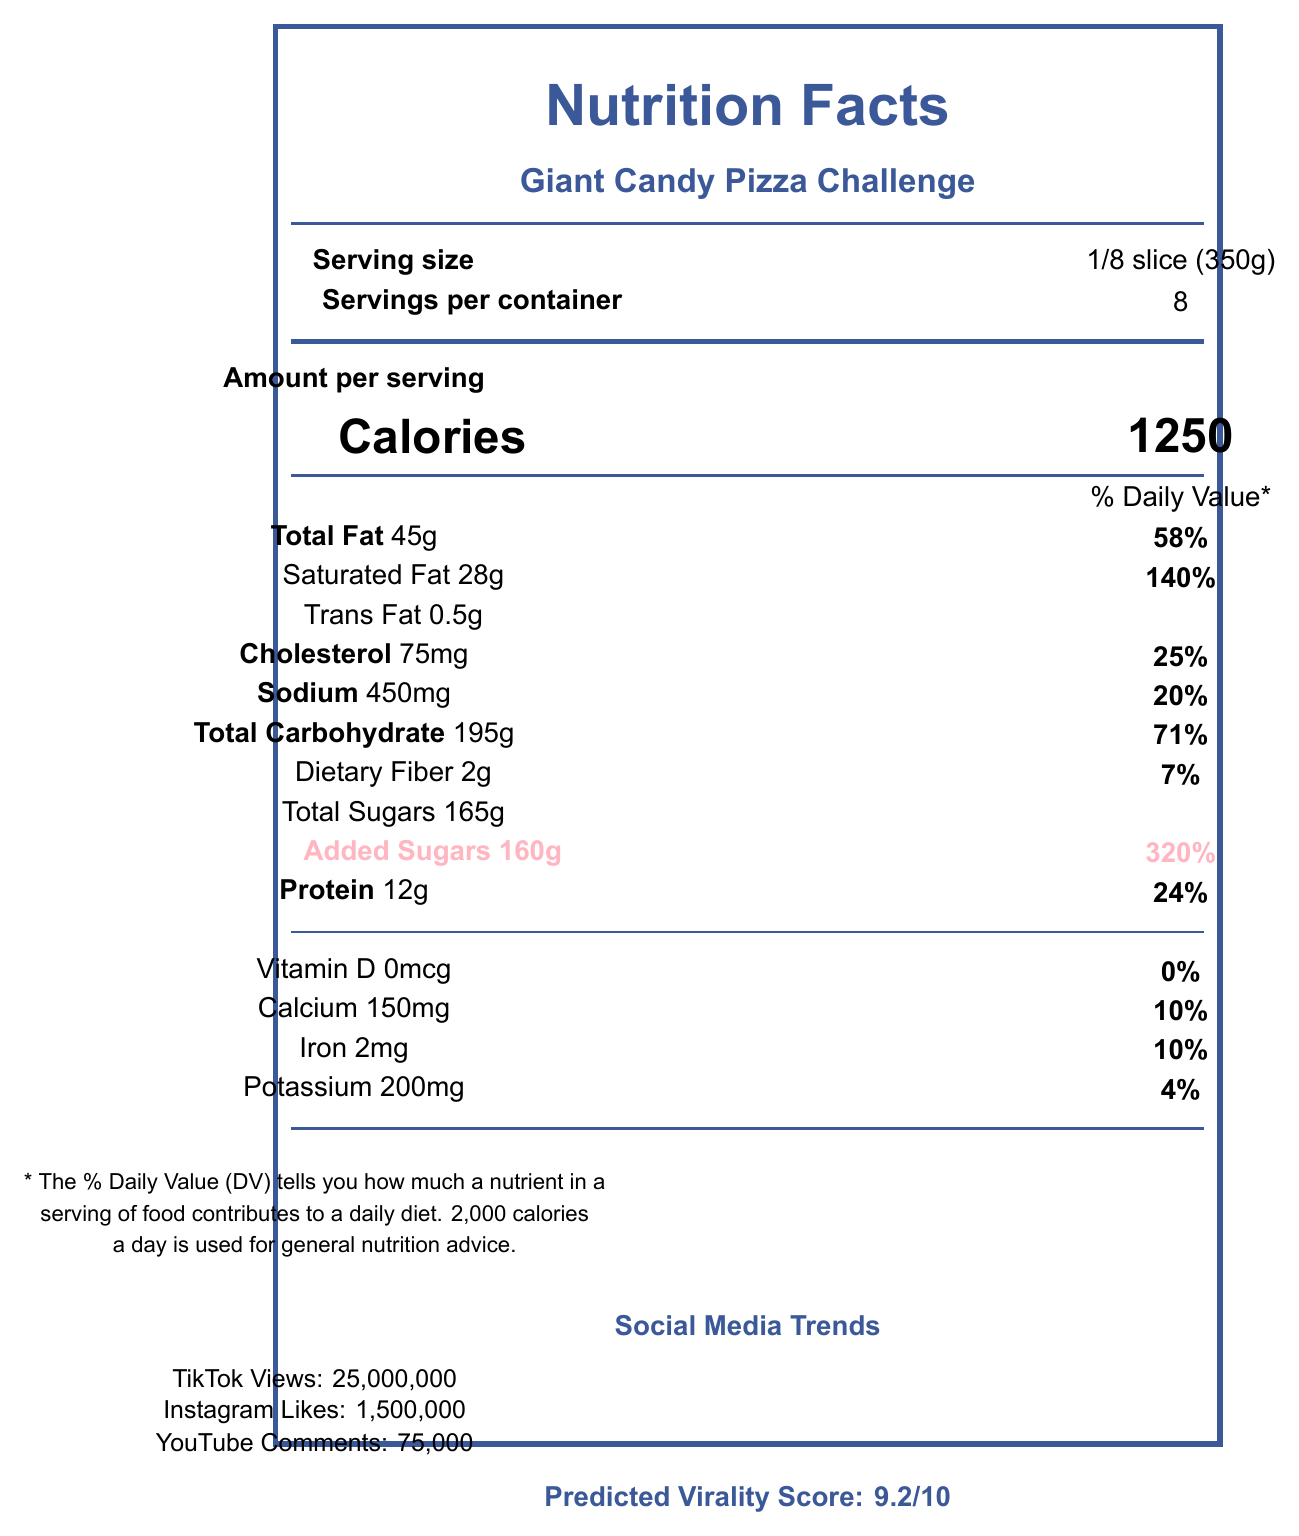what is the serving size? The document specifies the serving size as "1/8 slice (350g)" next to the label "Serving size."
Answer: 1/8 slice (350g) how many servings are there per container? The document states that the number of servings per container is 8.
Answer: 8 how many calories are there per serving? The document shows that each serving has 1250 calories next to the label "Calories."
Answer: 1250 what is the total amount of sugars per serving? The document lists "Total Sugars 165g" in the nutrition facts section.
Answer: 165g how much added sugar is in one serving? The document specifically mentions "Added Sugars 160g" in the nutrition facts section.
Answer: 160g what is the predicted virality score of this food challenge? The document states "Predicted Virality Score: 9.2/10" in the social media section.
Answer: 9.2/10 what social media platform has the most views for this challenge? A. TikTok B. Instagram C. YouTube TikTok has 25,000,000 views, which is the highest among the listed platforms.
Answer: A what percentage of the daily value of saturated fat is in one serving? A. 28% B. 140% C. 24% The document states "Saturated Fat 28g" and "140%" daily value.
Answer: B is there any vitamin D in this food item? The document shows "Vitamin D 0mcg" and "0%" daily value, indicating no vitamin D.
Answer: No summarize the main idea of the document. The document contains detailed nutritional facts and social media popularity statistics for the "Giant Candy Pizza Challenge," emphasizing its high sugar content and potential health impacts along with its viral trend on social media.
Answer: The document provides nutritional information and social media statistics for the "Giant Candy Pizza Challenge". It includes serving size, calories, macronutrient values, and social media trends, highlighting its high sugar content and predicted virality. how much Protein does one serving contain? The document lists "Protein 12g" in the nutrition facts section.
Answer: 12g which ingredient is present in the highest quantity in this food item? While quantities aren't given for each ingredient, "Sugar" is listed first, which generally means it's present in the highest quantity.
Answer: Sugar how many total carbohydrates are there per serving? The document lists "Total Carbohydrate 195g" in the nutrition facts section.
Answer: 195g what is the percentage of the daily value for sodium per serving? The document specifies "Sodium 450mg" and "20%" daily value.
Answer: 20% what are the potential health impacts of consuming this food item? The document provides a health impact warning stating that consuming this item may lead to significant blood sugar spikes and contribute to various health problems.
Answer: Consuming this food item may lead to significant spikes in blood sugar levels and contribute to various health issues. which nutrient has the highest daily value percentage in one serving? A. Total Fat B. Protein C. Added Sugars Added Sugars have a daily value percentage of 320%, which is the highest among the listed nutrients.
Answer: C is dietary fiber content more than 5g per serving? The document lists "Dietary Fiber 2g," which is less than 5g per serving.
Answer: No what are some popular hashtags associated with this food challenge? The document lists these hashtags under "popularChallengeHashtags".
Answer: #GiantCandyPizzaChallenge, #SugarOverload, #EpicFoodChallenge which ingredient contributes to the color of this food item? The document lists "Food Coloring (Red 40, Yellow 5, Blue 1)" as ingredients which are responsible for the color.
Answer: Food Coloring (Red 40, Yellow 5, Blue 1) what is the source of protein in this food item? The document lists ingredients but does not specify the source of protein.
Answer: I don't know 